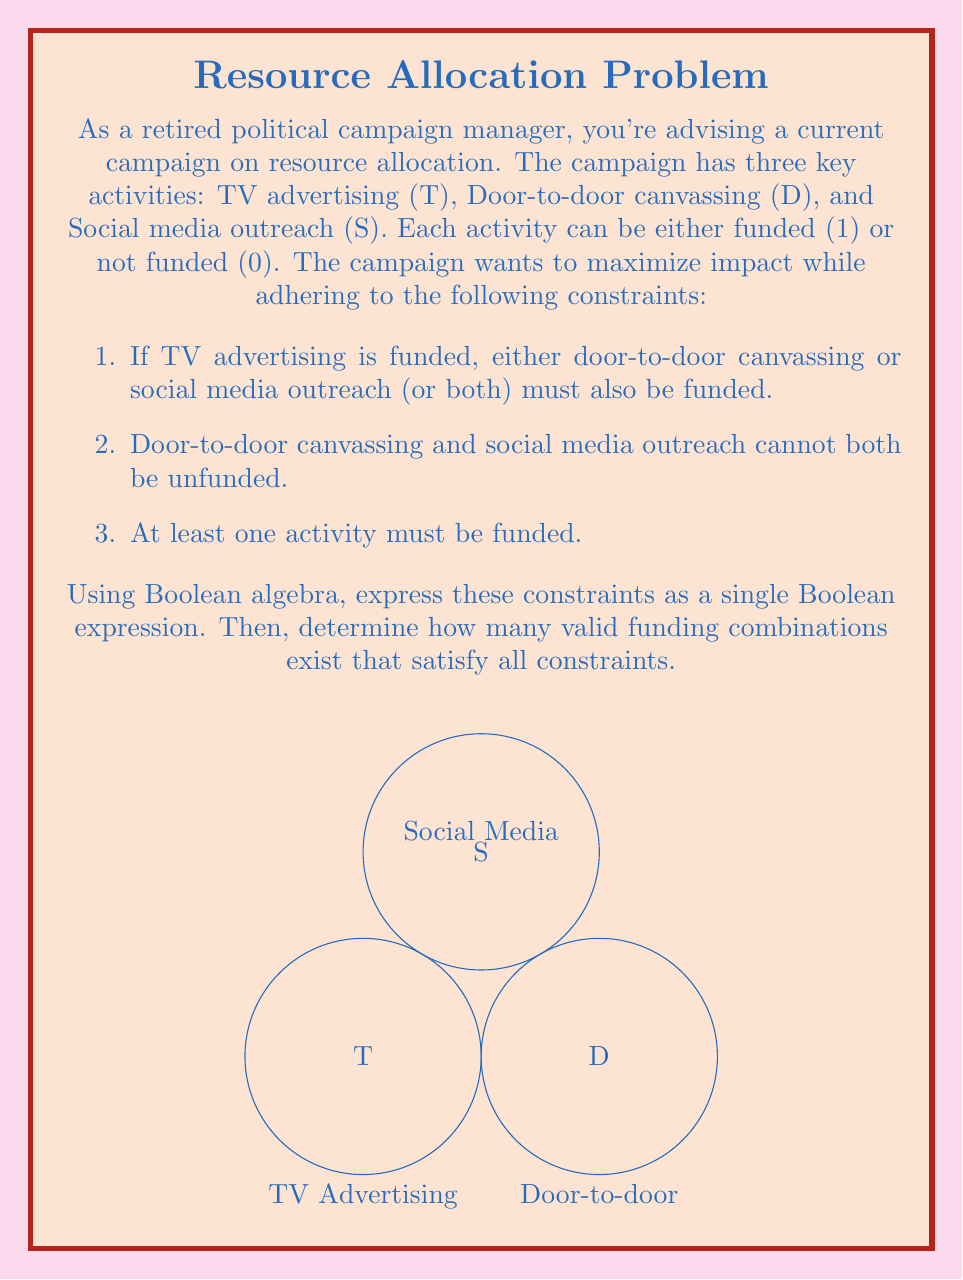Give your solution to this math problem. Let's approach this step-by-step:

1) First, let's express each constraint as a Boolean expression:

   Constraint 1: $T \implies (D \lor S)$ which is equivalent to $\overline{T} \lor D \lor S$
   Constraint 2: $\overline{(\overline{D} \land \overline{S})}$ which is equivalent to $D \lor S$
   Constraint 3: $T \lor D \lor S$

2) Now, we need to combine these constraints using AND operations:

   $(\overline{T} \lor D \lor S) \land (D \lor S) \land (T \lor D \lor S)$

3) This can be simplified:
   - The middle term $(D \lor S)$ is redundant as it's included in the last term.
   - The last term $(T \lor D \lor S)$ is always true when the first term is true.

   So our final Boolean expression is simply: $\overline{T} \lor D \lor S$

4) To count valid combinations, we can list all possibilities:
   - 001 (S only)
   - 010 (D only)
   - 011 (D and S)
   - 101 (T and S)
   - 110 (T and D)
   - 111 (All funded)

5) There are 6 valid combinations in total.

This Boolean expression and count ensure that if TV advertising is funded, at least one other activity is funded; door-to-door and social media can't both be unfunded; and at least one activity is always funded.
Answer: $\overline{T} \lor D \lor S$; 6 combinations 